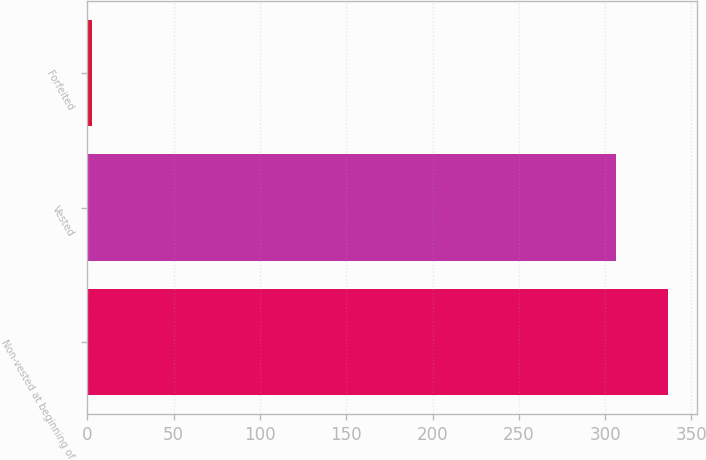<chart> <loc_0><loc_0><loc_500><loc_500><bar_chart><fcel>Non-vested at beginning of<fcel>Vested<fcel>Forfeited<nl><fcel>336.6<fcel>306<fcel>3<nl></chart> 